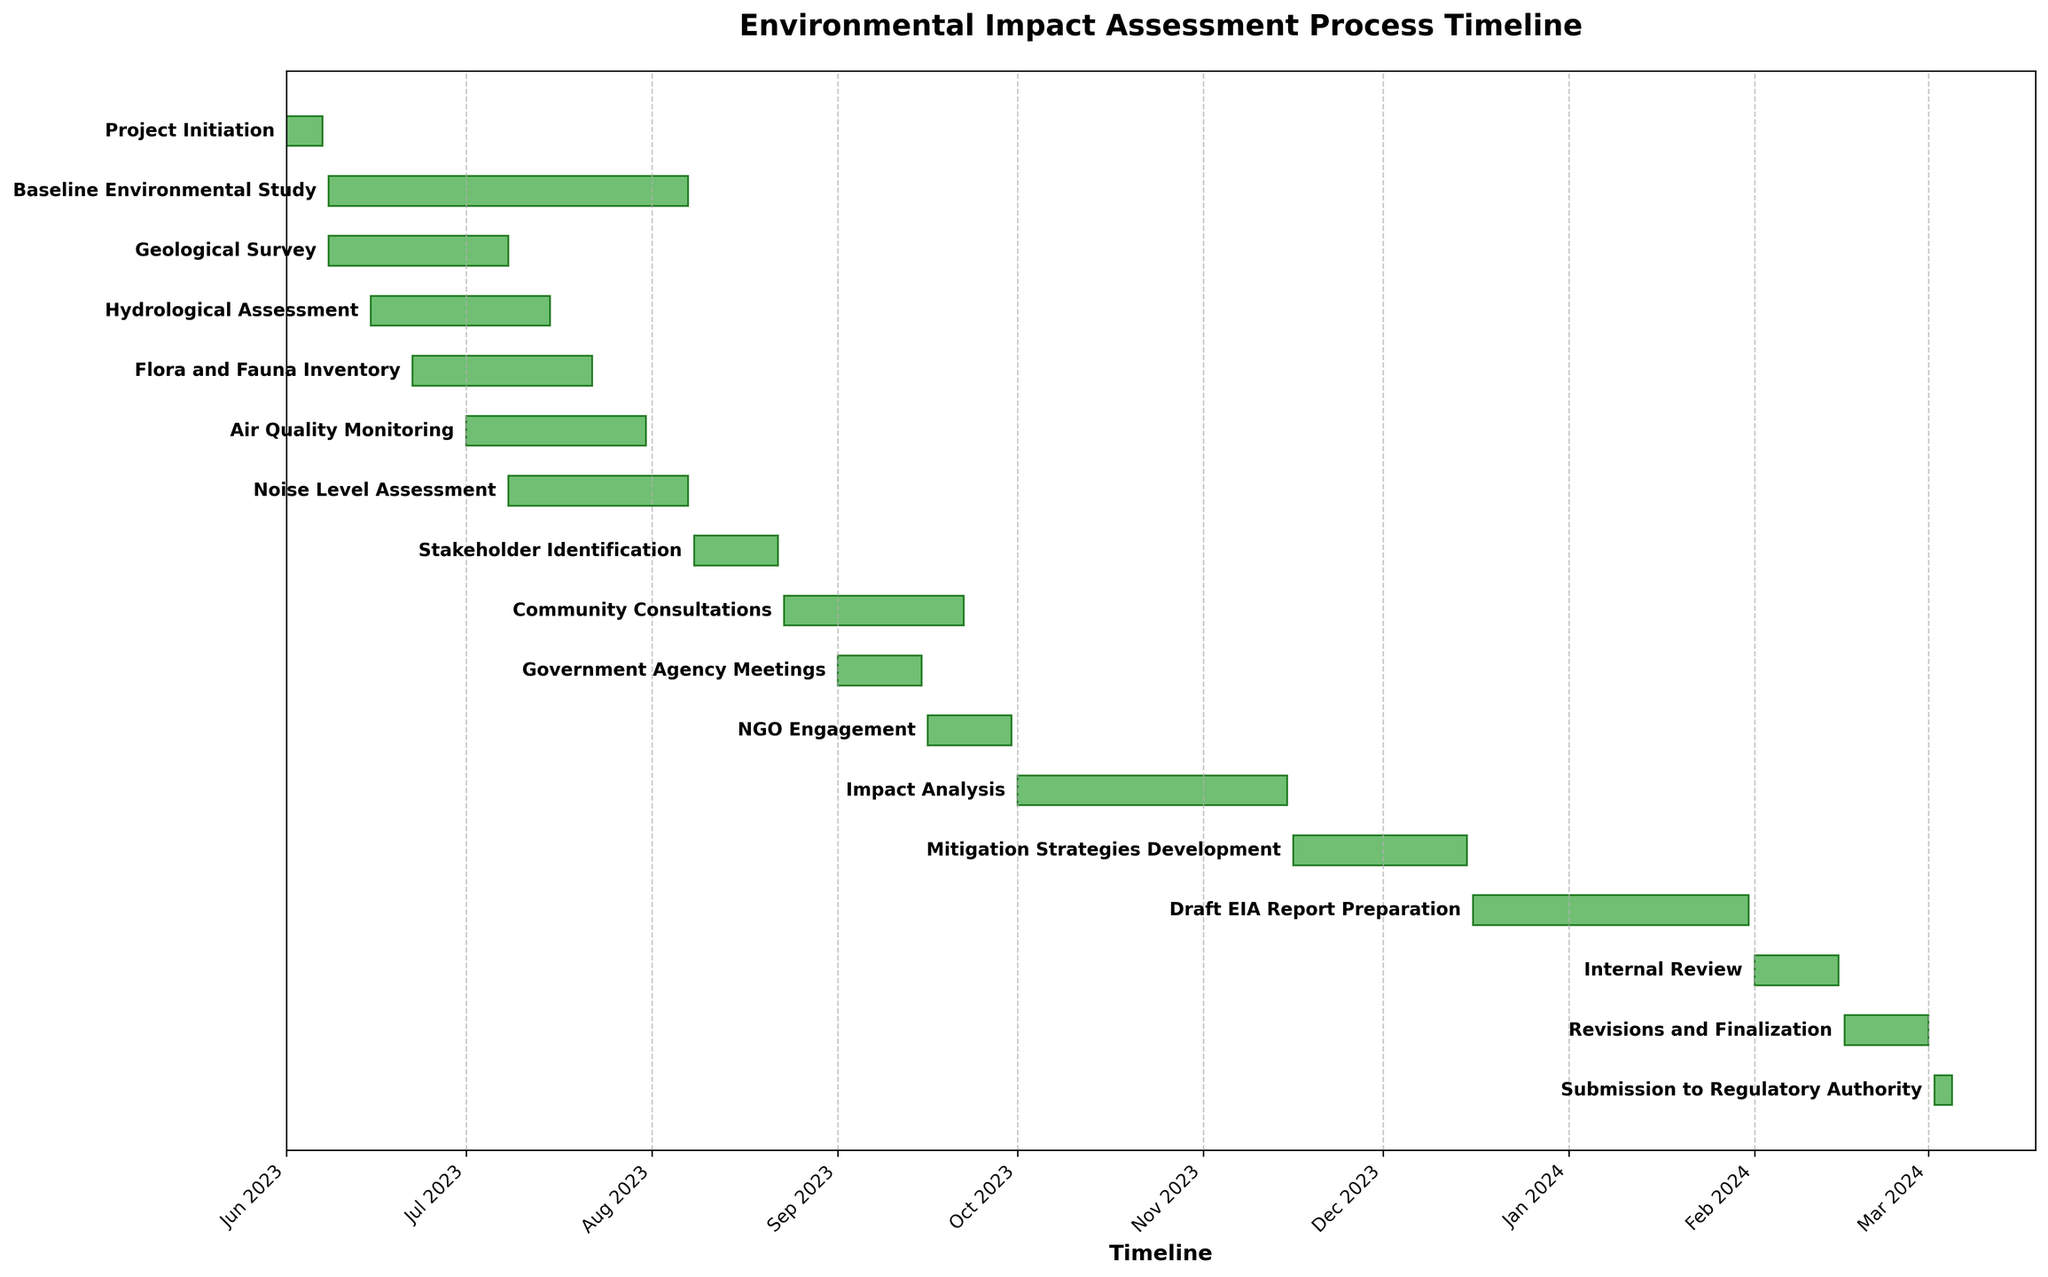What is the title of the figure? The title is located at the top of the figure, usually in a bold font. It provides an overview of what the entire chart is about. By reading the text at the top, we can determine the title.
Answer: Environmental Impact Assessment Process Timeline How many tasks are displayed on the Gantt Chart? Each task is represented by a horizontal bar in the figure. By counting these bars, we can determine the total number of tasks.
Answer: 17 When does the "Baseline Environmental Study" end? Locate the "Baseline Environmental Study" bar on the Gantt Chart and move to the end of the bar. The end date will be shown next to or at the end of the bar.
Answer: 2023-08-07 Which task has the longest duration? To find the task with the longest duration, compare the length of each horizontal bar. The longest bar on the Gantt Chart corresponds to the task with the longest duration.
Answer: Baseline Environmental Study Which task starts immediately after "Project Initiation"? Find "Project Initiation" on the Gantt Chart and identify the end date. The next task(s) that starts right after this date is the answer.
Answer: Baseline Environmental Study, Geological Survey, Hydrological Assessment, Flora and Fauna Inventory How long does the "Mitigation Strategies Development" task last? Find the "Mitigation Strategies Development" bar and note the duration or number of days it spans.
Answer: 29 days Which task overlaps with both the "Geological Survey" and "Flora and Fauna Inventory"? Identify the time period where the "Geological Survey" and "Flora and Fauna Inventory" tasks overlap, and look for any other task that also spans this period.
Answer: Hydrological Assessment When do stakeholder-related activities begin and end in the process? Locate the first and last stakeholder-related tasks on the chart, which include activities like Stakeholder Identification, Community Consultations, Government Agency Meetings, and NGO Engagement. Note the start date of the first task and end date of the last task.
Answer: 2023-08-08 to 2023-09-30 What is the total duration from the start of "Project Initiation" to the end of "Submission to Regulatory Authority"? Determine the start date of the "Project Initiation" task and the end date of the "Submission to Regulatory Authority". Calculate the difference between these two dates.
Answer: 279 days Which two tasks conclude in the first week of August 2023? Examine the end dates of each task and identify which ones finish within the first seven days of August 2023.
Answer: Baseline Environmental Study, Noise Level Assessment 